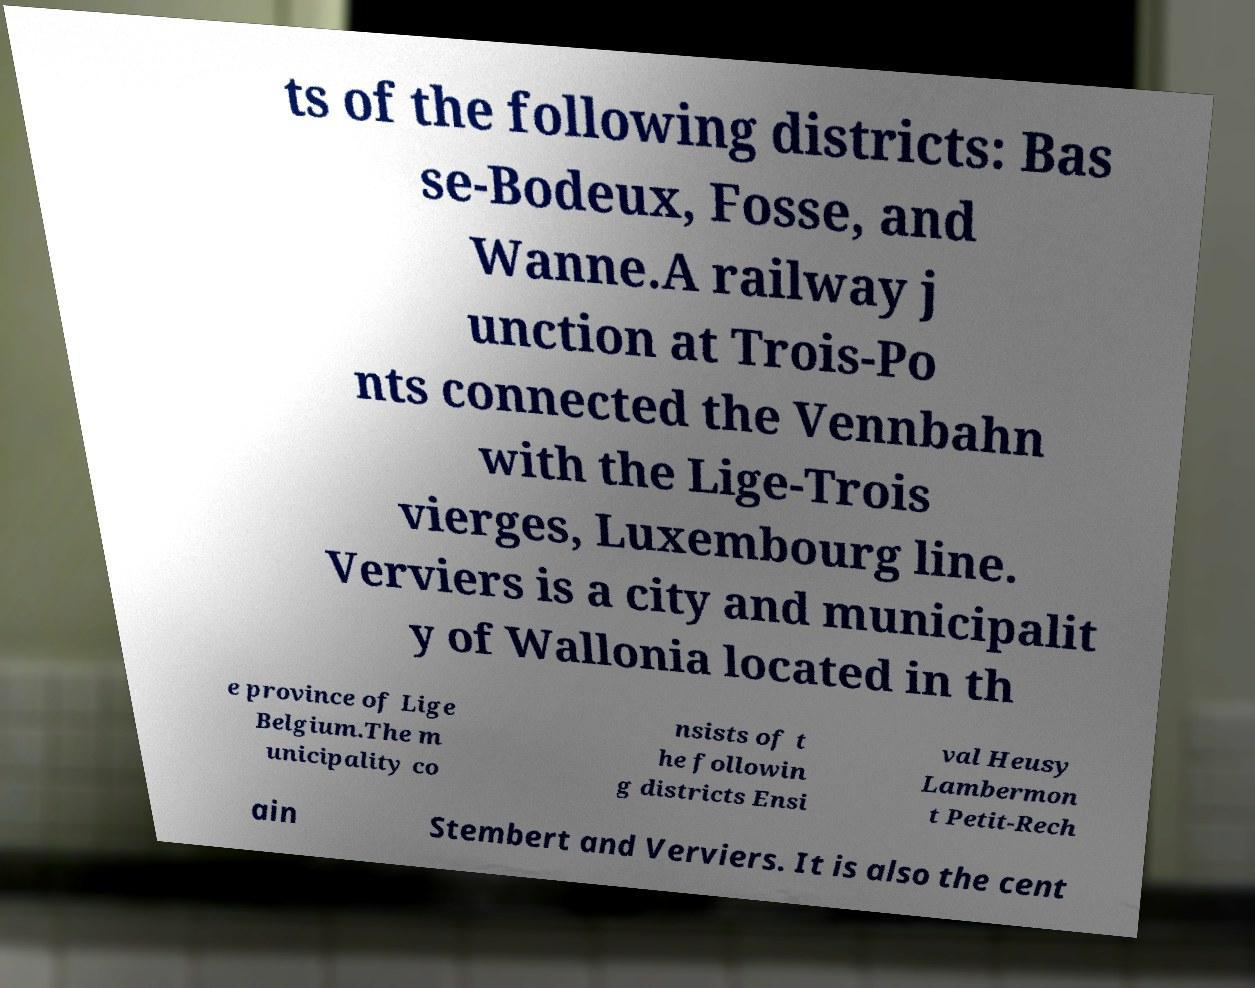What messages or text are displayed in this image? I need them in a readable, typed format. ts of the following districts: Bas se-Bodeux, Fosse, and Wanne.A railway j unction at Trois-Po nts connected the Vennbahn with the Lige-Trois vierges, Luxembourg line. Verviers is a city and municipalit y of Wallonia located in th e province of Lige Belgium.The m unicipality co nsists of t he followin g districts Ensi val Heusy Lambermon t Petit-Rech ain Stembert and Verviers. It is also the cent 